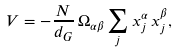<formula> <loc_0><loc_0><loc_500><loc_500>V = - \frac { N } { d _ { G } } \, \Omega _ { \alpha \beta } \sum _ { j } x _ { j } ^ { \alpha } \, x _ { j } ^ { \beta } ,</formula> 